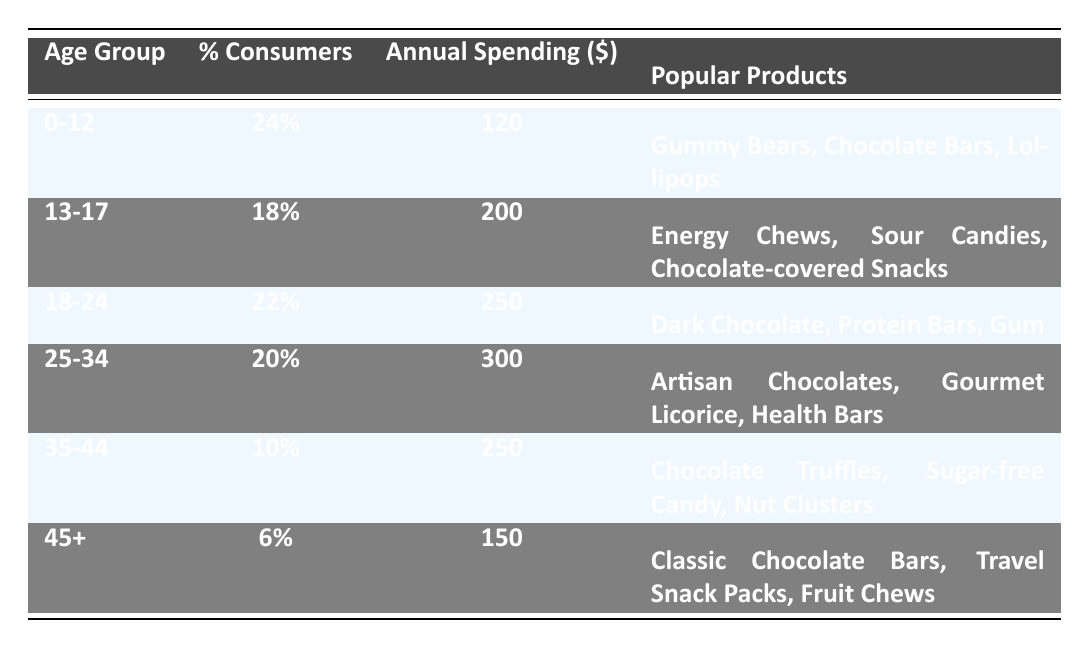What percentage of consumers are aged 0-12? The table clearly lists the age group 0-12 under the column "% Consumers," which shows that 24% of confectionery consumers belong to this age group.
Answer: 24% Which age group has the highest annual confectionery spending? Comparing the annual spending amounts across all age groups, the group aged 25-34 has the highest with an annual spending of 300 dollars.
Answer: 25-34 What is the combined percentage of consumers aged 13-24? To find the combined percentage, we add the percentage of consumers in the 13-17 (18%) and 18-24 (22%) age groups, resulting in 18 + 22 = 40%.
Answer: 40% Is the percentage of consumers aged 45+ greater than those aged 0-12? By looking at the table, 45+ has a percentage of 6% which is less than 24% for the 0-12 age group. Thus, the statement is false.
Answer: No What is the average annual spending for the age groups 35-44 and 45+? First, obtain the annual spending for both groups: 250 for 35-44 and 150 for 45+. Adding them gives 250 + 150 = 400. There are 2 groups, so the average is 400 / 2 = 200.
Answer: 200 Which age group spends the least on confectionery annually? By examining the spending amounts, the age group 45+ has the least annual spending at 150 dollars.
Answer: 45+ How many popular products are associated with the 25-34 age group? The table lists three popular products for the 25-34 age group: Artisan Chocolates, Gourmet Licorice, and Health Bars. Hence, the total is three.
Answer: 3 Are chocolate-covered snacks popular among consumers aged 13-17? According to the table, chocolate-covered snacks are listed as one of the popular products for the 13-17 age group. Therefore, the statement is true.
Answer: Yes What is the difference in annual spending between the 18-24 and 35-44 age groups? The annual spending for the 18-24 age group is 250, while for the 35-44 age group, it is 250 as well. The difference is calculated as 250 - 250 = 0.
Answer: 0 